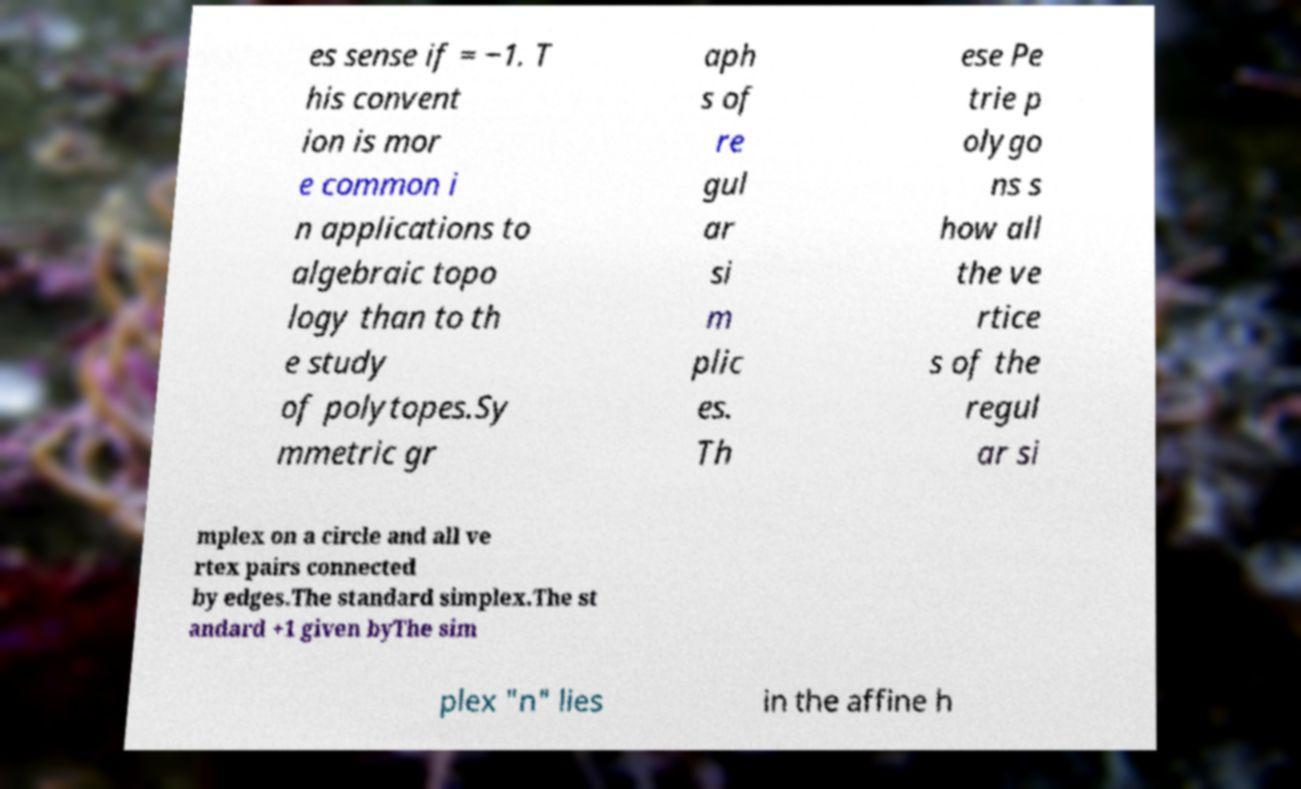Can you accurately transcribe the text from the provided image for me? es sense if = −1. T his convent ion is mor e common i n applications to algebraic topo logy than to th e study of polytopes.Sy mmetric gr aph s of re gul ar si m plic es. Th ese Pe trie p olygo ns s how all the ve rtice s of the regul ar si mplex on a circle and all ve rtex pairs connected by edges.The standard simplex.The st andard +1 given byThe sim plex "n" lies in the affine h 